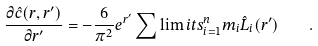Convert formula to latex. <formula><loc_0><loc_0><loc_500><loc_500>\frac { \partial \hat { c } ( r , r ^ { \prime } ) } { \partial r ^ { \prime } } = - \frac { 6 } { \pi ^ { 2 } } e ^ { r ^ { \prime } } \sum \lim i t s _ { i = 1 } ^ { n } m _ { i } \hat { L } _ { i } ( r ^ { \prime } ) \quad .</formula> 